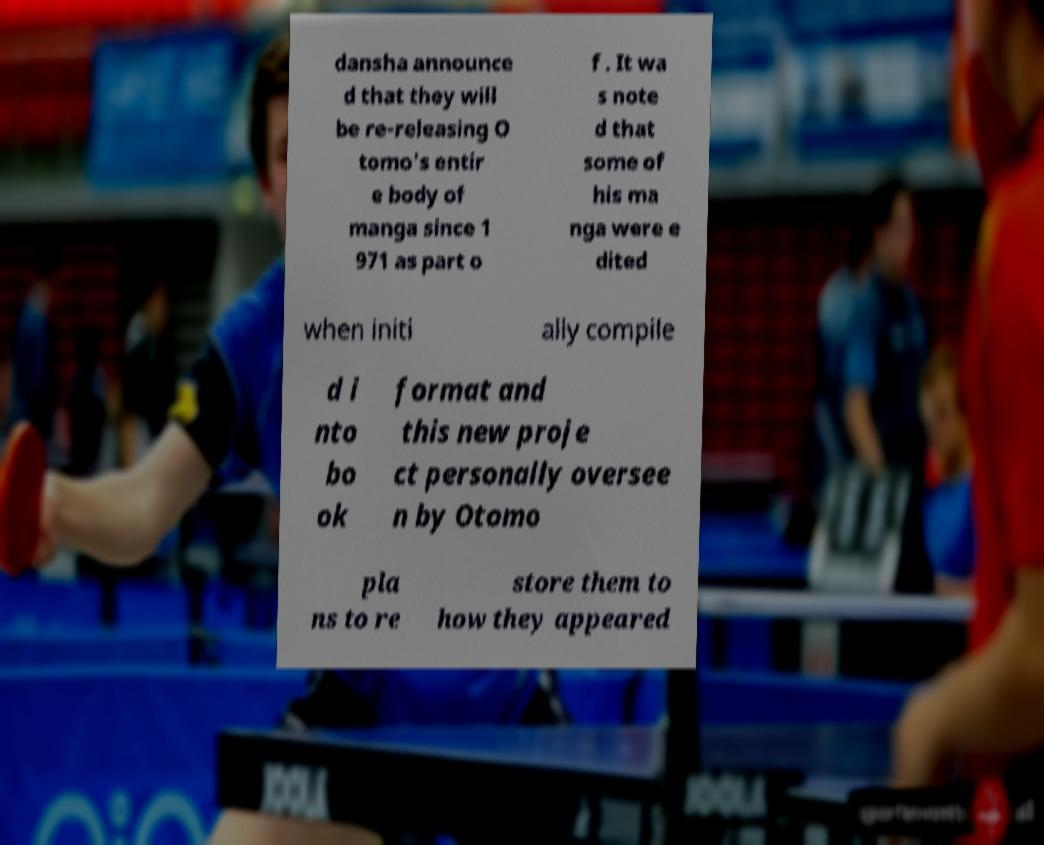Can you accurately transcribe the text from the provided image for me? dansha announce d that they will be re-releasing O tomo's entir e body of manga since 1 971 as part o f . It wa s note d that some of his ma nga were e dited when initi ally compile d i nto bo ok format and this new proje ct personally oversee n by Otomo pla ns to re store them to how they appeared 